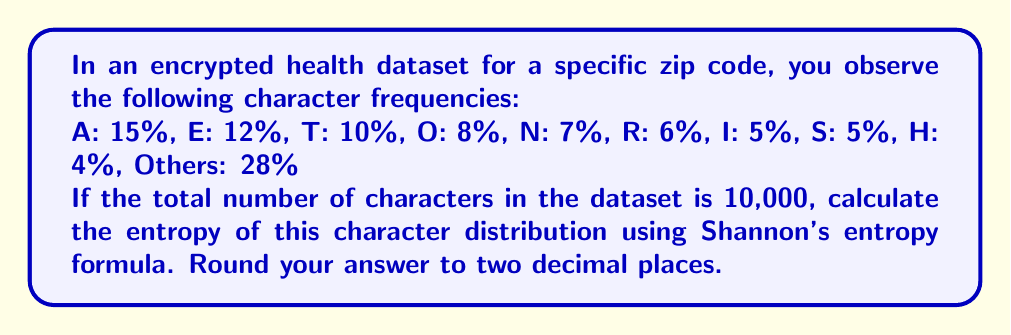Help me with this question. To calculate the entropy of the character distribution, we'll use Shannon's entropy formula:

$$H = -\sum_{i=1}^n p_i \log_2(p_i)$$

Where $p_i$ is the probability of each character occurring.

Step 1: Convert percentages to probabilities
A: 0.15, E: 0.12, T: 0.10, O: 0.08, N: 0.07, R: 0.06, I: 0.05, S: 0.05, H: 0.04, Others: 0.28

Step 2: Calculate $-p_i \log_2(p_i)$ for each character
A: $-0.15 \log_2(0.15) = 0.4105$
E: $-0.12 \log_2(0.12) = 0.3672$
T: $-0.10 \log_2(0.10) = 0.3322$
O: $-0.08 \log_2(0.08) = 0.2916$
N: $-0.07 \log_2(0.07) = 0.2679$
R: $-0.06 \log_2(0.06) = 0.2442$
I: $-0.05 \log_2(0.05) = 0.2161$
S: $-0.05 \log_2(0.05) = 0.2161$
H: $-0.04 \log_2(0.04) = 0.1856$
Others: $-0.28 \log_2(0.28) = 0.5159$

Step 3: Sum all the calculated values
$H = 0.4105 + 0.3672 + 0.3322 + 0.2916 + 0.2679 + 0.2442 + 0.2161 + 0.2161 + 0.1856 + 0.5159 = 3.0473$

Step 4: Round to two decimal places
$H \approx 3.05$ bits
Answer: 3.05 bits 